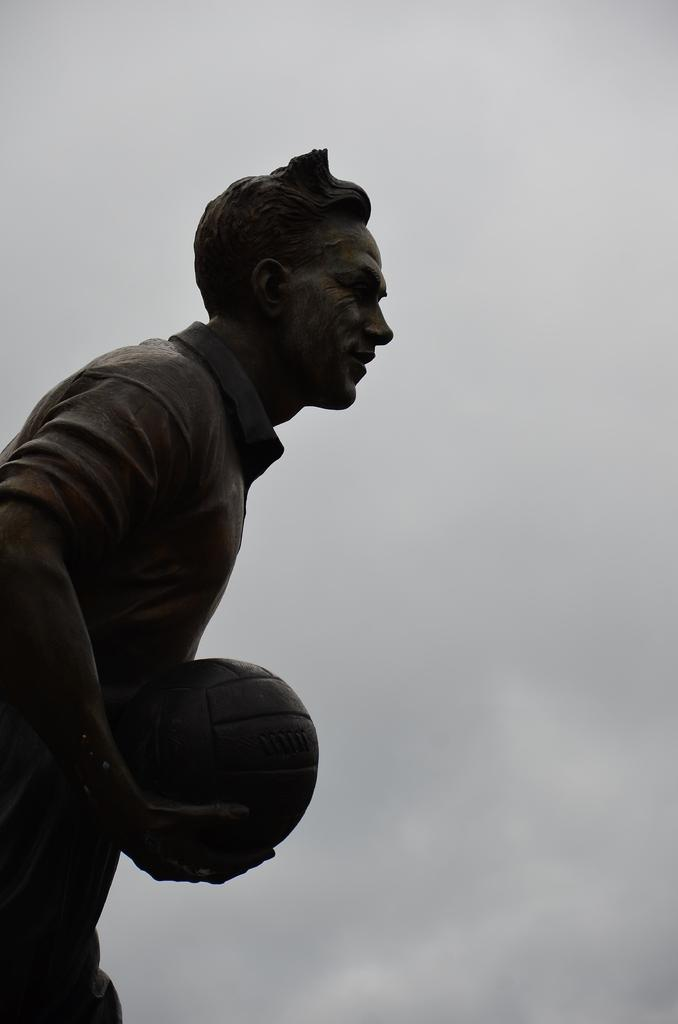What is the main subject of the image? There is a sculpture in the image. Can you describe the sculpture? The sculpture is of a man. What is the man holding in the sculpture? The man is holding a ball in the sculpture. What type of quilt is draped over the man in the sculpture? There is no quilt present in the image; it is a sculpture of a man holding a ball. How is the string used in the sculpture? There is no string present in the sculpture; it is a man holding a ball. 